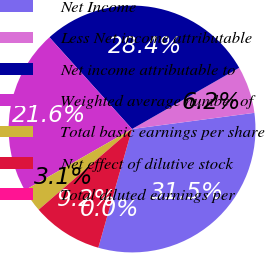Convert chart to OTSL. <chart><loc_0><loc_0><loc_500><loc_500><pie_chart><fcel>Net Income<fcel>Less Net income attributable<fcel>Net income attributable to<fcel>Weighted average number of<fcel>Total basic earnings per share<fcel>Net effect of dilutive stock<fcel>Total diluted earnings per<nl><fcel>31.5%<fcel>6.17%<fcel>28.41%<fcel>21.59%<fcel>3.08%<fcel>9.25%<fcel>0.0%<nl></chart> 